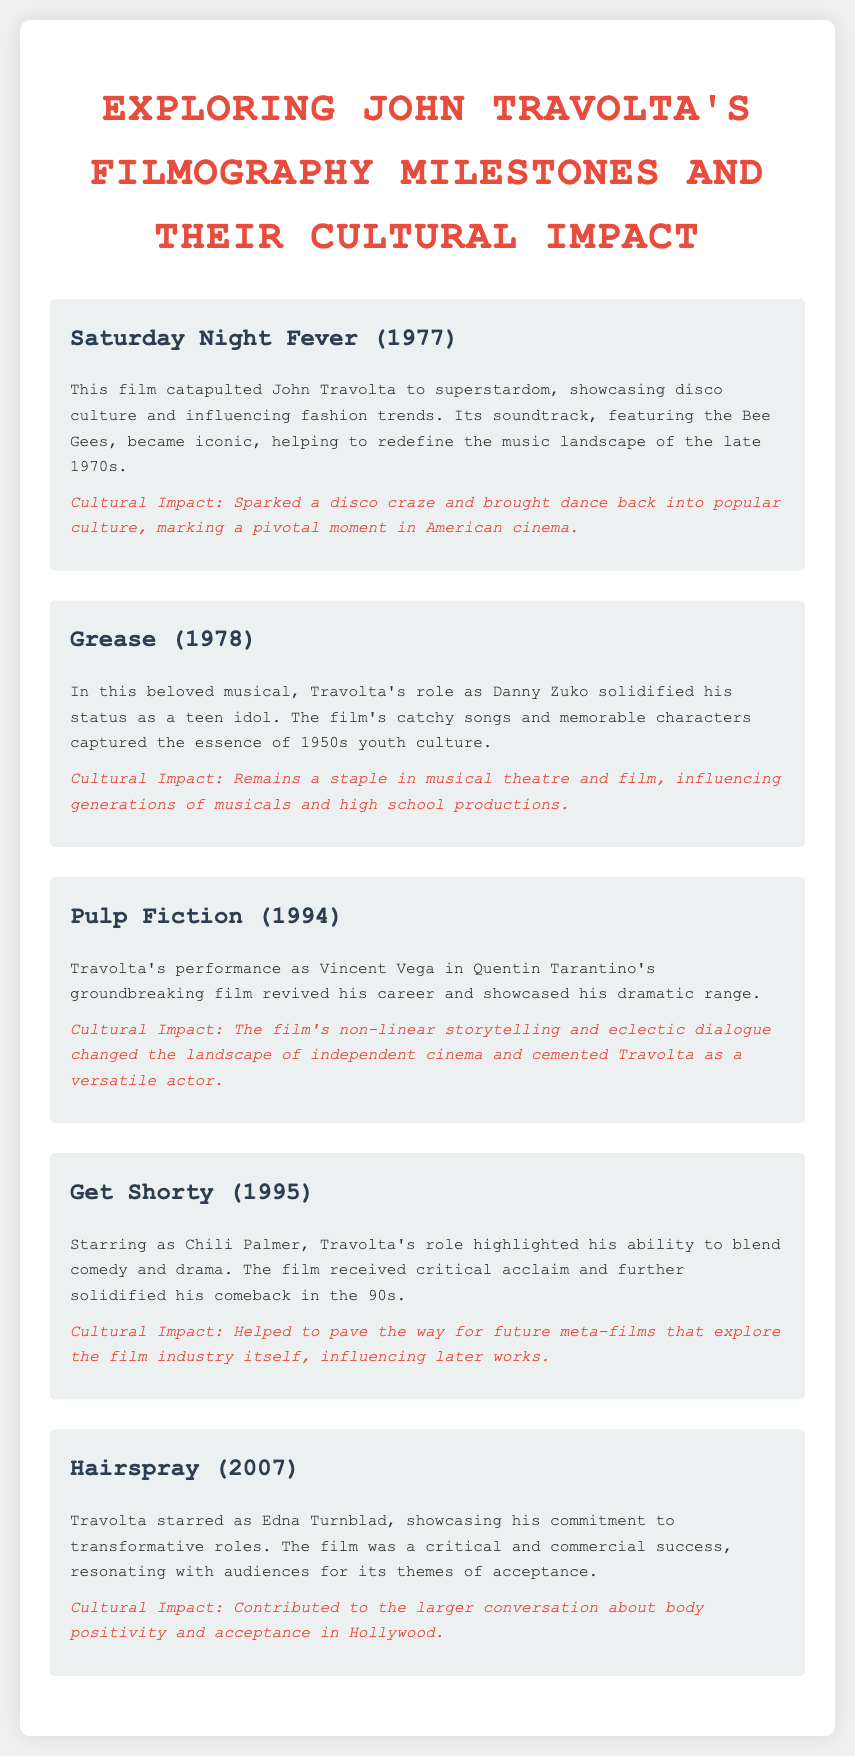What is the title of the film that catapulted John Travolta to superstardom? The title of the film that catapulted John Travolta to superstardom is "Saturday Night Fever."
Answer: Saturday Night Fever In which year was "Grease" released? The document states that "Grease" was released in 1978.
Answer: 1978 What role did John Travolta play in "Pulp Fiction"? The document specifies that he played the role of Vincent Vega in "Pulp Fiction."
Answer: Vincent Vega How many films are mentioned in the document? The document lists five films in total.
Answer: Five What theme did "Hairspray" resonate with audiences? According to the document, "Hairspray" resonated with audiences for its theme of acceptance.
Answer: Acceptance Which film is noted for its non-linear storytelling? The document indicates that "Pulp Fiction" is noted for its non-linear storytelling.
Answer: Pulp Fiction Which decade did the film "Saturday Night Fever" influence fashion trends? The document mentions that "Saturday Night Fever" influenced fashion trends in the 1970s.
Answer: 1970s What is John Travolta's character's name in "Get Shorty"? The document states that John Travolta's character in "Get Shorty" is named Chili Palmer.
Answer: Chili Palmer 